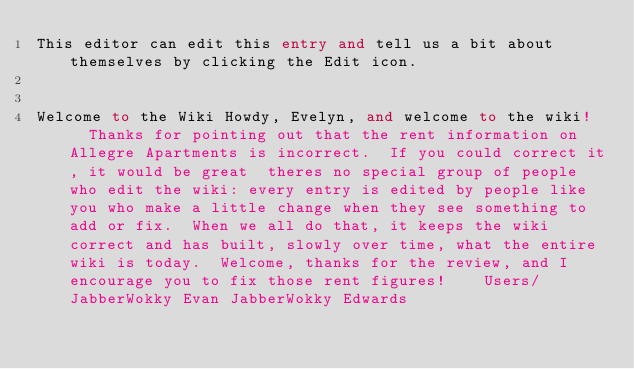<code> <loc_0><loc_0><loc_500><loc_500><_FORTRAN_>This editor can edit this entry and tell us a bit about themselves by clicking the Edit icon.


Welcome to the Wiki Howdy, Evelyn, and welcome to the wiki!   Thanks for pointing out that the rent information on Allegre Apartments is incorrect.  If you could correct it, it would be great  theres no special group of people who edit the wiki: every entry is edited by people like you who make a little change when they see something to add or fix.  When we all do that, it keeps the wiki correct and has built, slowly over time, what the entire wiki is today.  Welcome, thanks for the review, and I encourage you to fix those rent figures!    Users/JabberWokky Evan JabberWokky Edwards
</code> 